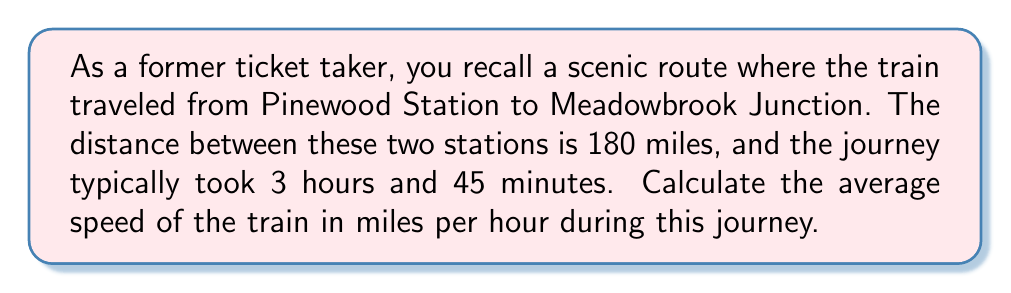Can you answer this question? To calculate the average speed of the train, we'll use the formula:

$$\text{Speed} = \frac{\text{Distance}}{\text{Time}}$$

Given:
- Distance: 180 miles
- Time: 3 hours and 45 minutes

First, we need to convert the time to hours:
3 hours and 45 minutes = 3.75 hours

Now, let's plug the values into our formula:

$$\text{Speed} = \frac{180 \text{ miles}}{3.75 \text{ hours}}$$

Performing the division:

$$\text{Speed} = 48 \text{ miles per hour}$$

Therefore, the average speed of the train during this journey was 48 miles per hour.
Answer: $48 \text{ miles per hour}$ 